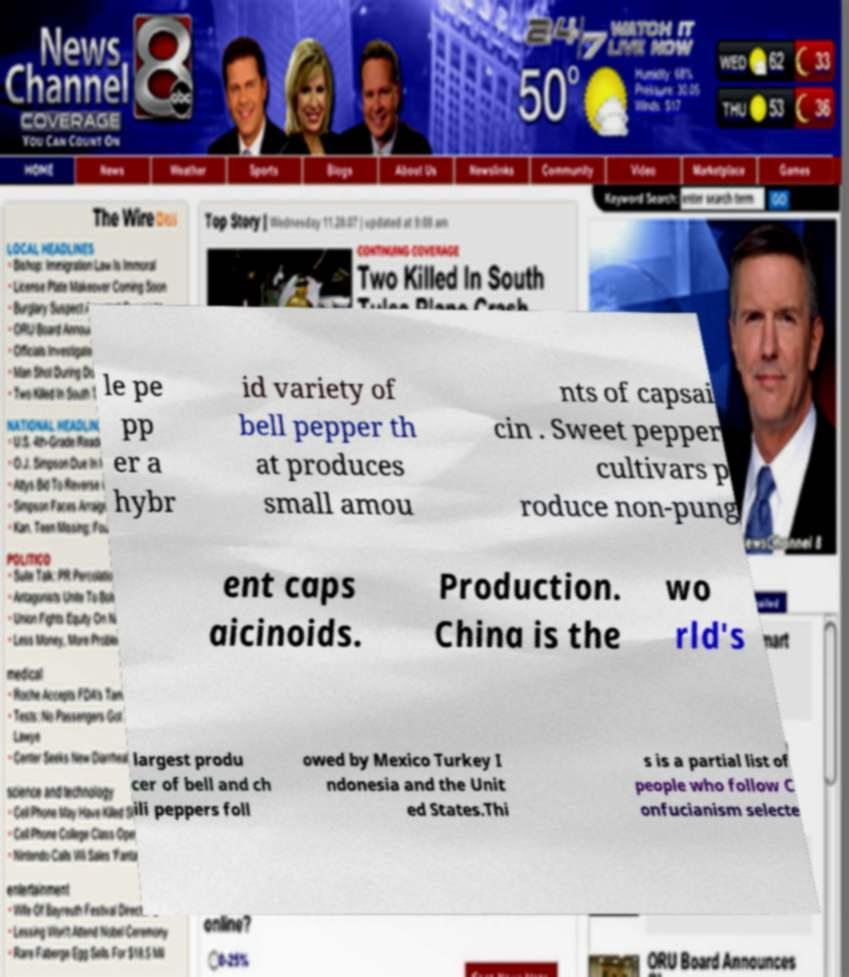Please read and relay the text visible in this image. What does it say? le pe pp er a hybr id variety of bell pepper th at produces small amou nts of capsai cin . Sweet pepper cultivars p roduce non-pung ent caps aicinoids. Production. China is the wo rld's largest produ cer of bell and ch ili peppers foll owed by Mexico Turkey I ndonesia and the Unit ed States.Thi s is a partial list of people who follow C onfucianism selecte 